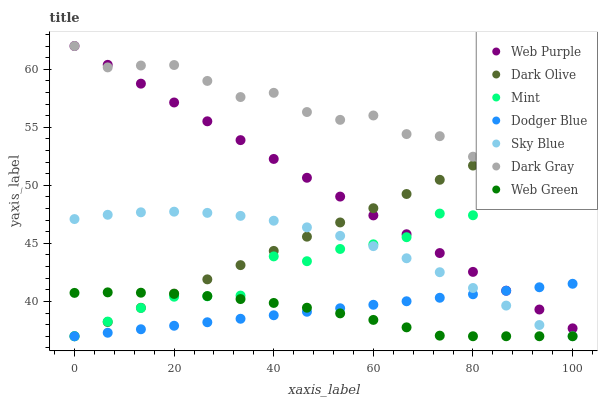Does Web Green have the minimum area under the curve?
Answer yes or no. Yes. Does Dark Gray have the maximum area under the curve?
Answer yes or no. Yes. Does Dark Gray have the minimum area under the curve?
Answer yes or no. No. Does Web Green have the maximum area under the curve?
Answer yes or no. No. Is Dodger Blue the smoothest?
Answer yes or no. Yes. Is Dark Gray the roughest?
Answer yes or no. Yes. Is Web Green the smoothest?
Answer yes or no. No. Is Web Green the roughest?
Answer yes or no. No. Does Dark Olive have the lowest value?
Answer yes or no. Yes. Does Dark Gray have the lowest value?
Answer yes or no. No. Does Web Purple have the highest value?
Answer yes or no. Yes. Does Web Green have the highest value?
Answer yes or no. No. Is Web Green less than Web Purple?
Answer yes or no. Yes. Is Web Purple greater than Sky Blue?
Answer yes or no. Yes. Does Dodger Blue intersect Mint?
Answer yes or no. Yes. Is Dodger Blue less than Mint?
Answer yes or no. No. Is Dodger Blue greater than Mint?
Answer yes or no. No. Does Web Green intersect Web Purple?
Answer yes or no. No. 